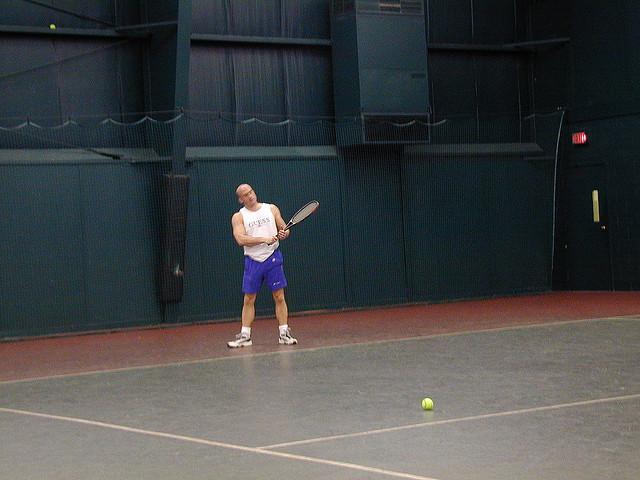What does the man have on his feet?
Quick response, please. Shoes. How many tennis balls are visible in this picture?
Be succinct. 1. Where is the tennis ball?
Give a very brief answer. Ground. What does the sign above the door say?
Answer briefly. Exit. 